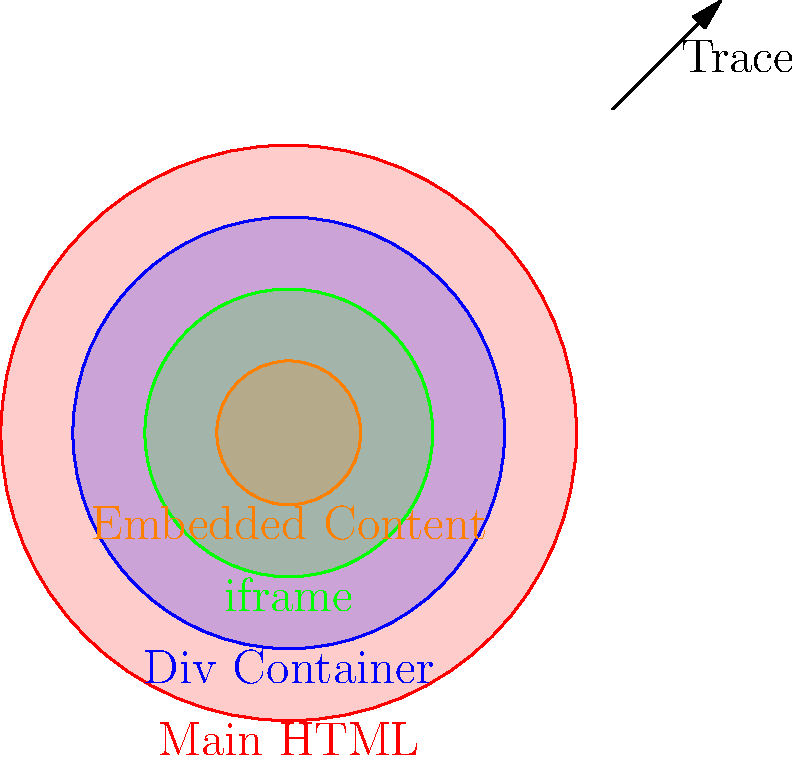You've encountered a website with multiple layers of nested elements, including several iframes. Your task is to trace the source of an embedded iframe containing suspicious content. Which HTML attribute should you primarily focus on to determine the origin of the embedded content? To trace the source of an embedded iframe within a complex HTML structure, follow these steps:

1. Locate the iframe element in the HTML code.
2. The key attribute for determining the source of an iframe's content is the "src" attribute.
3. The "src" attribute specifies the URL of the embedded content.
4. This URL can be absolute (e.g., "https://example.com/content.html") or relative (e.g., "/content.html").
5. If the URL is relative, you'll need to consider the base URL of the containing document.
6. Check if there are any JavaScript manipulations of the iframe's src attribute, which could dynamically change the source.
7. Look for any additional attributes like "srcdoc" which might contain inline HTML instead of an external source.
8. If dealing with multiple nested iframes, repeat this process for each layer, tracing from the outermost to the innermost iframe.

By focusing on the "src" attribute, you can effectively trace the origin of the embedded content, which is crucial for digital forensics analysis of website structures.
Answer: src attribute 